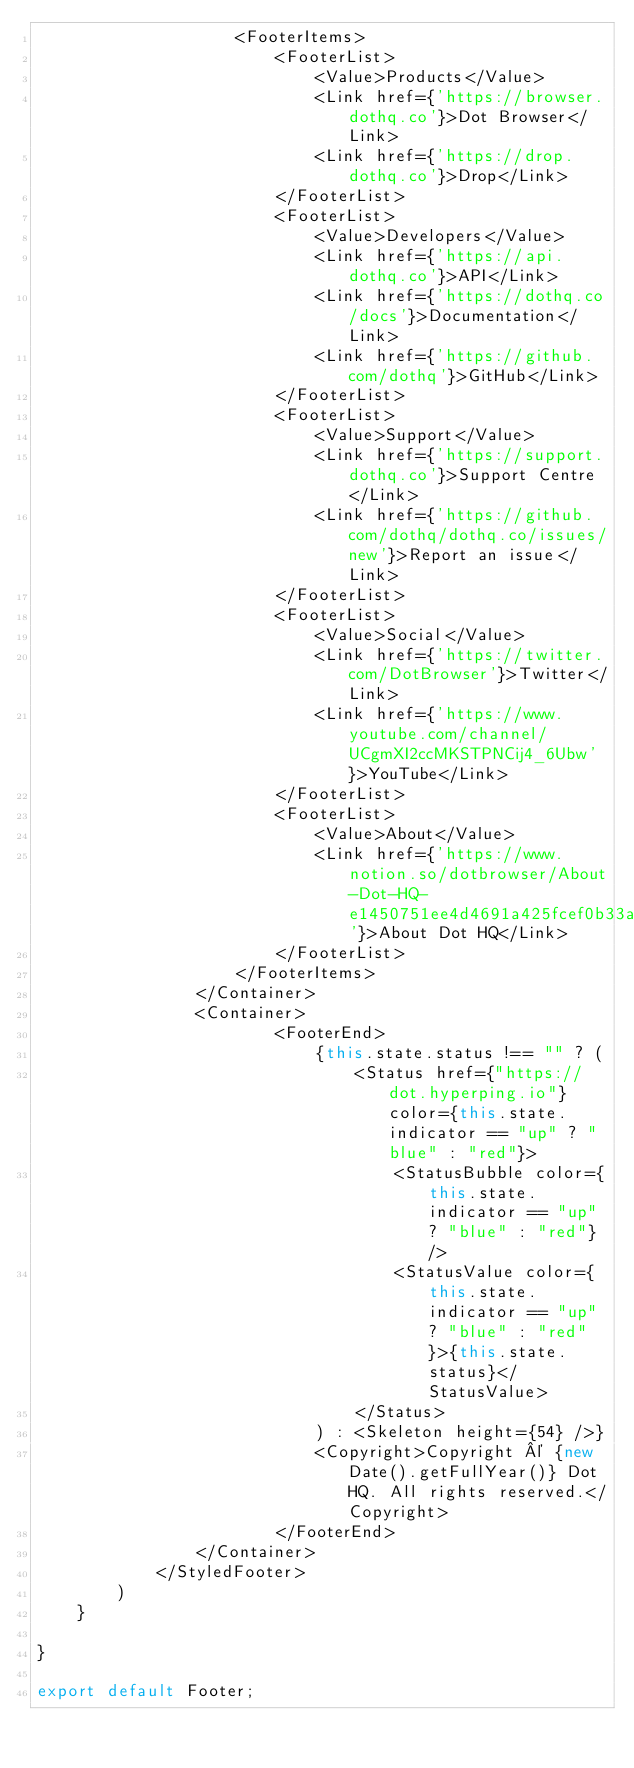Convert code to text. <code><loc_0><loc_0><loc_500><loc_500><_TypeScript_>                    <FooterItems>
                        <FooterList>
                            <Value>Products</Value>
                            <Link href={'https://browser.dothq.co'}>Dot Browser</Link>
                            <Link href={'https://drop.dothq.co'}>Drop</Link>
                        </FooterList>
                        <FooterList>
                            <Value>Developers</Value>
                            <Link href={'https://api.dothq.co'}>API</Link>
                            <Link href={'https://dothq.co/docs'}>Documentation</Link>
                            <Link href={'https://github.com/dothq'}>GitHub</Link>
                        </FooterList>
                        <FooterList>
                            <Value>Support</Value>
                            <Link href={'https://support.dothq.co'}>Support Centre</Link>
                            <Link href={'https://github.com/dothq/dothq.co/issues/new'}>Report an issue</Link>
                        </FooterList>
                        <FooterList>
                            <Value>Social</Value>
                            <Link href={'https://twitter.com/DotBrowser'}>Twitter</Link>
                            <Link href={'https://www.youtube.com/channel/UCgmXI2ccMKSTPNCij4_6Ubw'}>YouTube</Link>
                        </FooterList>
                        <FooterList>
                            <Value>About</Value>
                            <Link href={'https://www.notion.so/dotbrowser/About-Dot-HQ-e1450751ee4d4691a425fcef0b33a732'}>About Dot HQ</Link>
                        </FooterList>
                    </FooterItems>
                </Container>
                <Container>
                        <FooterEnd>
                            {this.state.status !== "" ? ( 
                                <Status href={"https://dot.hyperping.io"}  color={this.state.indicator == "up" ? "blue" : "red"}>
                                    <StatusBubble color={this.state.indicator == "up" ? "blue" : "red"} />
                                    <StatusValue color={this.state.indicator == "up" ? "blue" : "red"}>{this.state.status}</StatusValue> 
                                </Status>
                            ) : <Skeleton height={54} />}
                            <Copyright>Copyright © {new Date().getFullYear()} Dot HQ. All rights reserved.</Copyright>
                        </FooterEnd>
                </Container>
            </StyledFooter>
        )
    }

}

export default Footer;</code> 